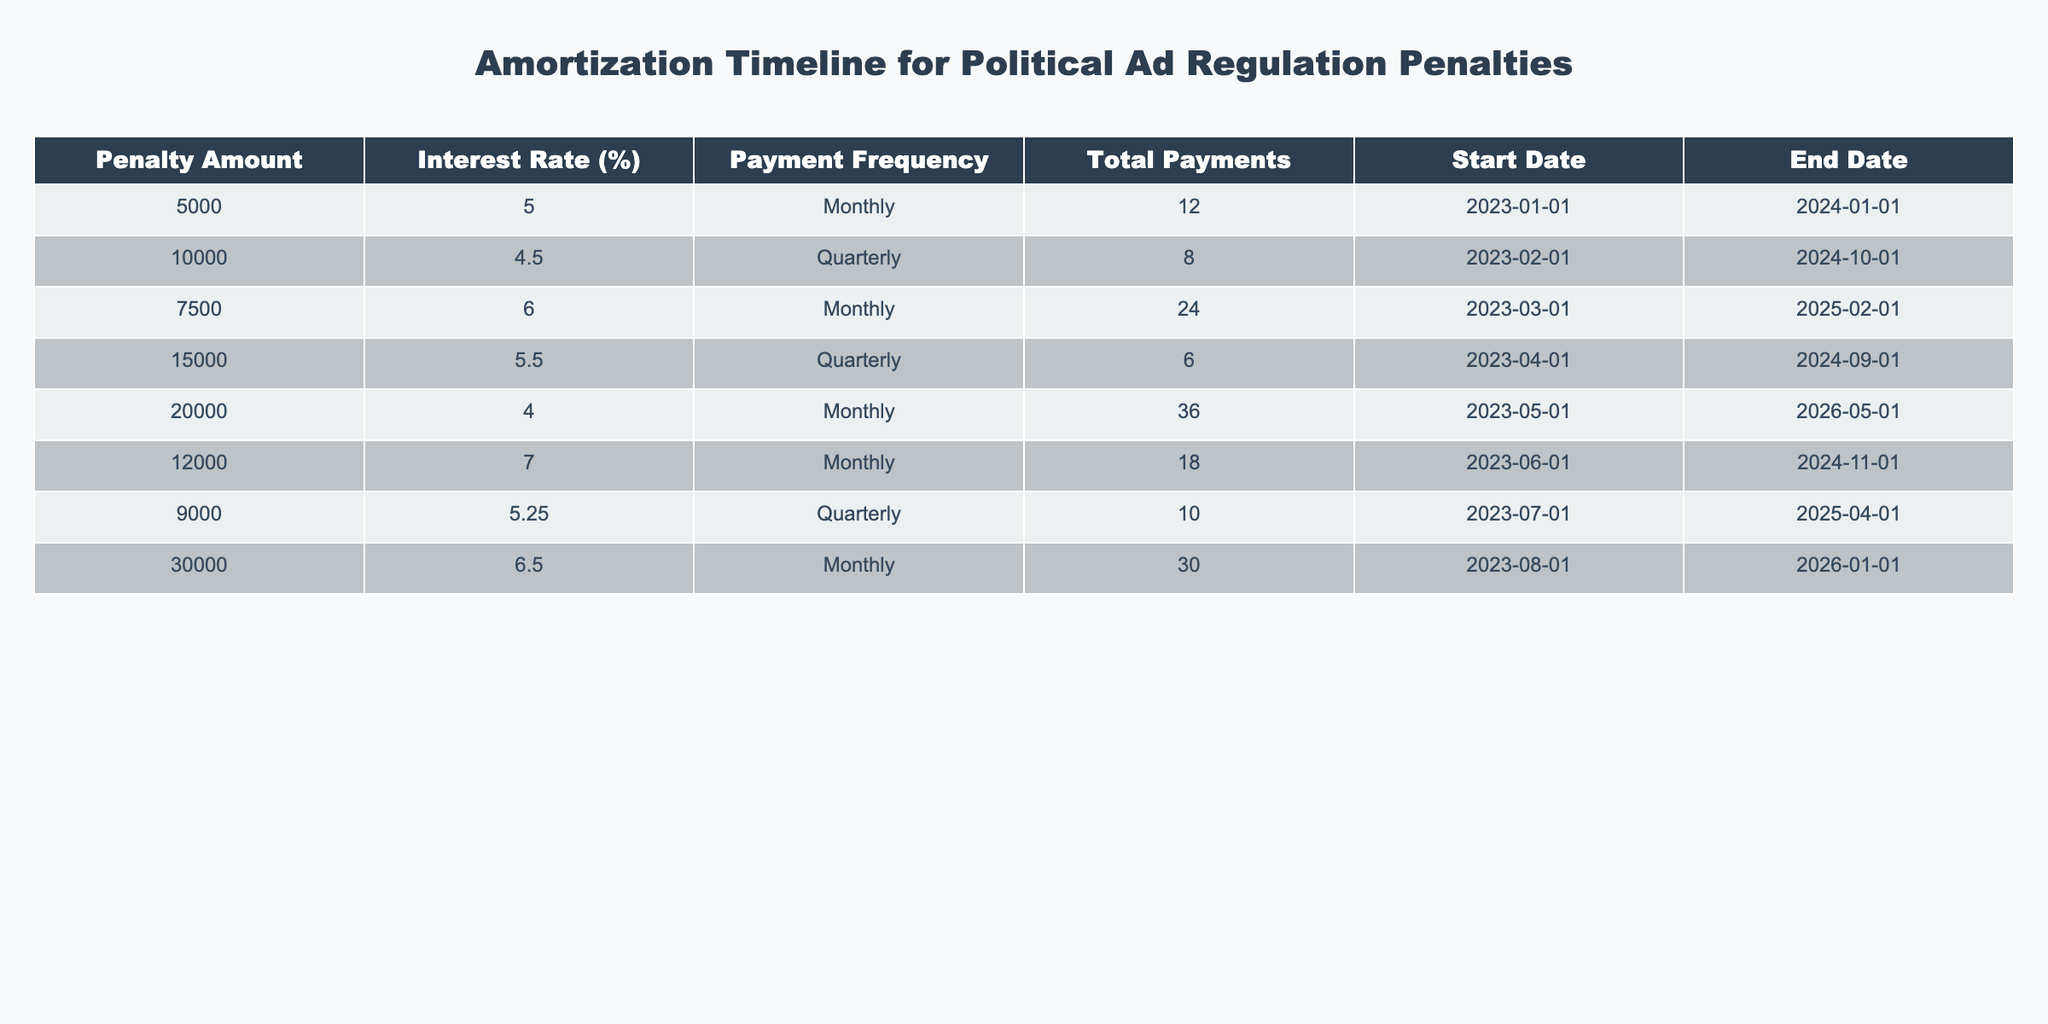What is the penalty amount for the entry with the highest interest rate? The entry with the highest interest rate is for 12000 with an interest rate of 7%. Thus, the penalty amount associated with that entry is 12000.
Answer: 12000 What is the total number of payments for penalties with a monthly payment frequency? The entries with a monthly payment frequency are for 5000 (12 payments), 7500 (24 payments), 20000 (36 payments), 12000 (18 payments), and 30000 (30 payments). If we sum these payments: 12 + 24 + 36 + 18 + 30 = 120.
Answer: 120 Is the penalty amount for all entries higher than 3000? Upon examining all entries: 5000, 10000, 7500, 15000, 20000, 12000, 9000, and 30000, all of these amounts exceed 3000. Therefore, the statement is true.
Answer: Yes What is the average penalty amount for all entries? To calculate the average penalty amount, we first sum all the penalty amounts: 5000 + 10000 + 7500 + 15000 + 20000 + 12000 + 9000 + 30000 = 100500. There are 8 entries, so the average is 100500 / 8 = 12562.5.
Answer: 12562.5 Which payment frequency has the longest total duration from start to end date? The entry with the longest duration is the one for 20000, which starts on 2023-05-01 and ends on 2026-05-01, totaling 36 months. This duration is longer than any other entry's duration based on the end dates provided.
Answer: Monthly (36 months) 